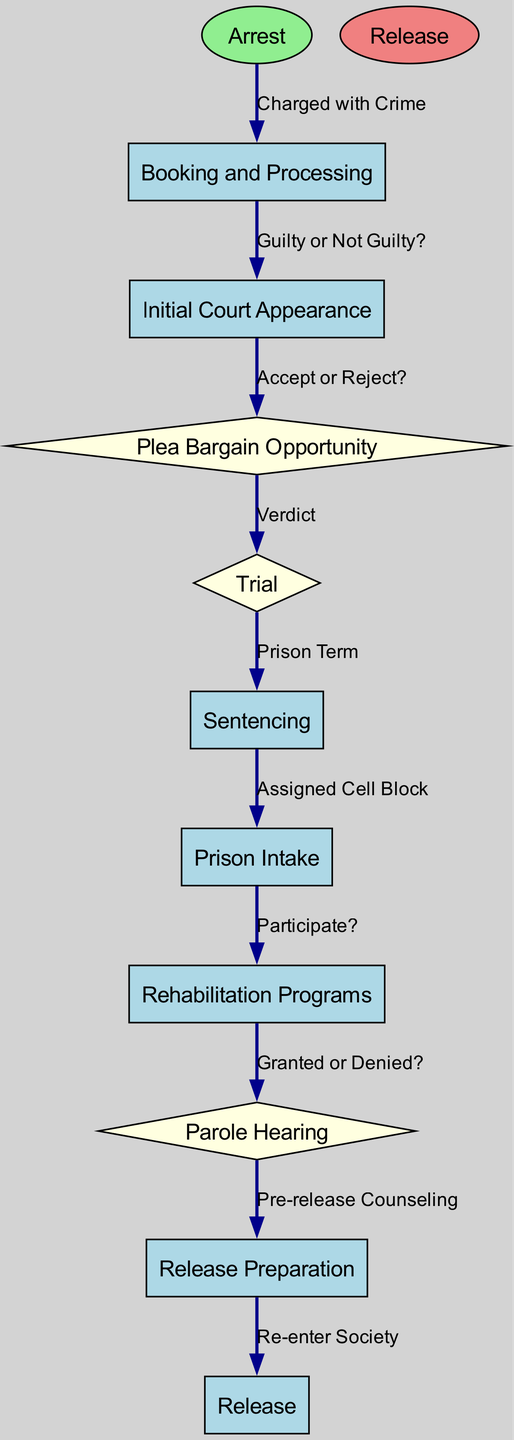What is the starting point of the journey? The journey begins at the node labeled "Arrest," which is the first step in the flow chart and represents where the journey initiates.
Answer: Arrest How many decision points are there in the diagram? The diagram identifies three specific decision points: "Plea Bargain Opportunity," "Trial," and "Parole Hearing." Therefore, by counting these distinct points, we determine that there are three decision points.
Answer: 3 What node follows "Initial Court Appearance"? The node "Plea Bargain Opportunity" is directly connected to "Initial Court Appearance," making it the subsequent step in the flow chart that follows after this court appearance.
Answer: Plea Bargain Opportunity What happens if the outcome is "Guilty" at the trial? If the verdict of the trial results in a "Guilty" outcome, the next step is "Sentencing," indicating that the individual will then move on to the sentencing phase of their journey through the legal system.
Answer: Sentencing What is the final stage in the journey? The final stage, representing the conclusion of the journey through the flow chart, is labeled "Release," which indicates the end of the flow where the individual re-enters society.
Answer: Release What decision follows the "Prison Intake"? After "Prison Intake," the decision point is whether to "Participate?" in rehabilitation programs, indicating a crucial choice that impacts the inmate's journey during incarceration.
Answer: Participate? If "Granted or Denied?" is the outcome of the Parole Hearing, what can happen next? If the parole hearing results in "Granted," then the next step is "Release Preparation," which facilitates the transition towards release; conversely, if "Denied," it would imply ongoing incarceration without release.
Answer: Release Preparation What edge connects "Trial" to "Sentencing"? The edge labeled "Verdict" serves to connect "Trial" to "Sentencing," representing the outcome of the trial that determines the sentencing phase based on the trial's results.
Answer: Verdict 